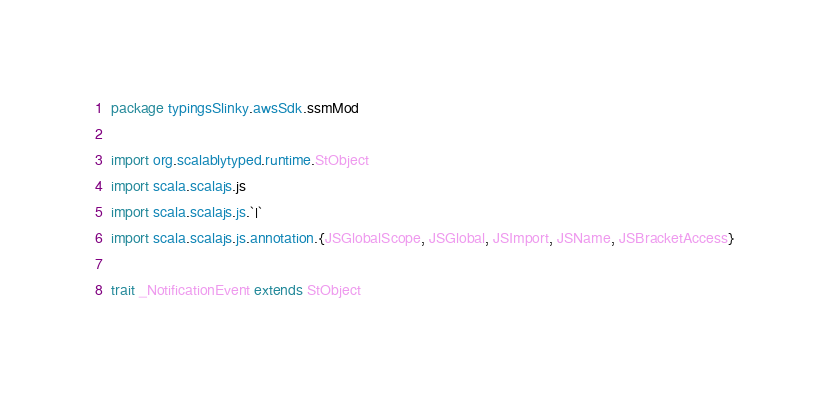Convert code to text. <code><loc_0><loc_0><loc_500><loc_500><_Scala_>package typingsSlinky.awsSdk.ssmMod

import org.scalablytyped.runtime.StObject
import scala.scalajs.js
import scala.scalajs.js.`|`
import scala.scalajs.js.annotation.{JSGlobalScope, JSGlobal, JSImport, JSName, JSBracketAccess}

trait _NotificationEvent extends StObject
</code> 